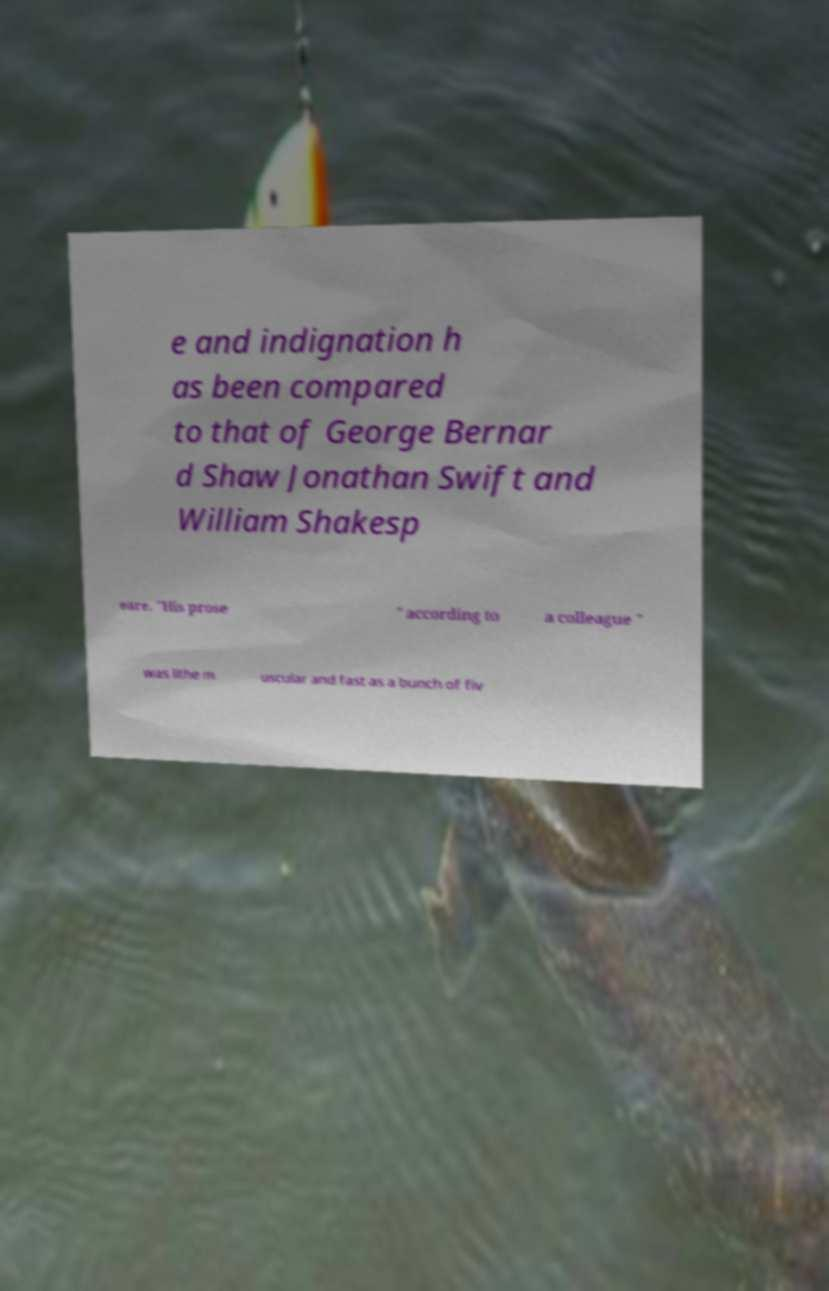What messages or text are displayed in this image? I need them in a readable, typed format. e and indignation h as been compared to that of George Bernar d Shaw Jonathan Swift and William Shakesp eare. "His prose " according to a colleague " was lithe m uscular and fast as a bunch of fiv 